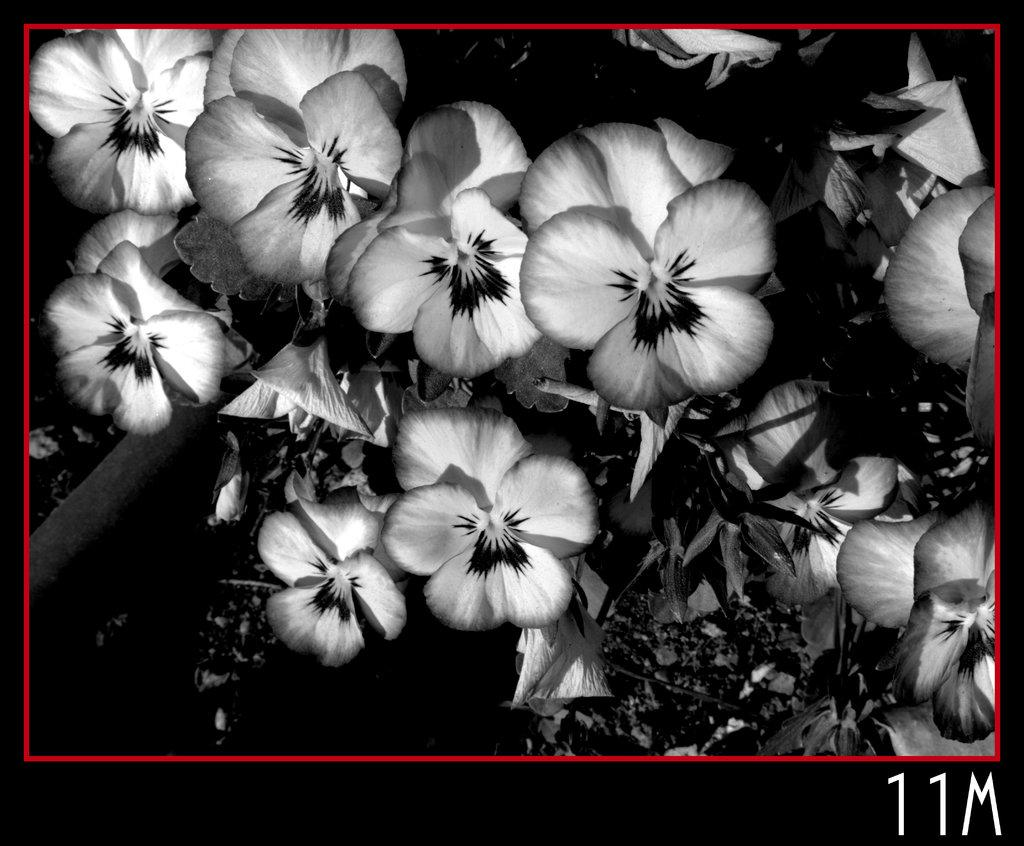What type of living organisms can be seen in the image? There are flowers and plants visible in the image. Can you describe the text at the bottom of the image? Unfortunately, the provided facts do not give any information about the text at the bottom of the image. What is the natural setting visible in the image? The natural setting includes flowers and plants. How many cracks can be seen on the girl's face in the image? There is no girl present in the image, so there are no cracks on her face. 